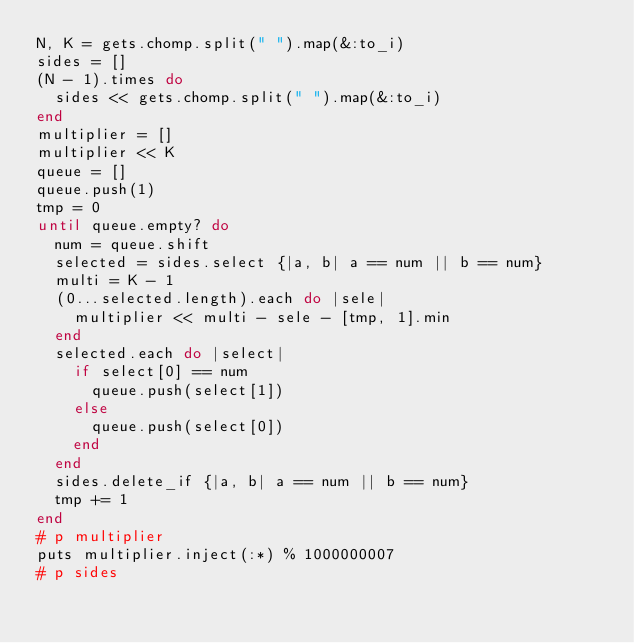Convert code to text. <code><loc_0><loc_0><loc_500><loc_500><_Ruby_>N, K = gets.chomp.split(" ").map(&:to_i)
sides = []
(N - 1).times do
  sides << gets.chomp.split(" ").map(&:to_i)
end
multiplier = []
multiplier << K
queue = []
queue.push(1)
tmp = 0
until queue.empty? do
  num = queue.shift
  selected = sides.select {|a, b| a == num || b == num}
  multi = K - 1
  (0...selected.length).each do |sele|
    multiplier << multi - sele - [tmp, 1].min
  end
  selected.each do |select|
    if select[0] == num
      queue.push(select[1])
    else
      queue.push(select[0])
    end
  end
  sides.delete_if {|a, b| a == num || b == num}
  tmp += 1
end
# p multiplier
puts multiplier.inject(:*) % 1000000007
# p sides</code> 